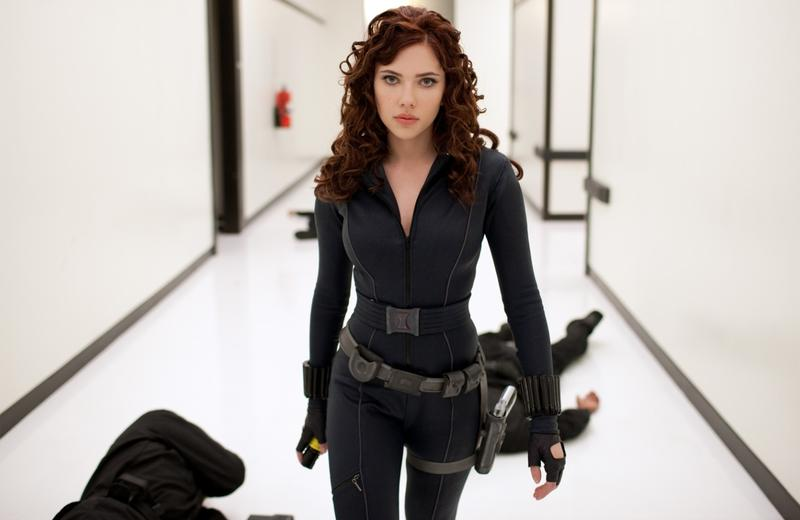Imagine the next scene in this story. In the next scene, the camera could pan out to reveal Black Widow bracing herself as more adversaries appear at the end of the corridor. Drawing her weapons from her holsters, she prepares for another intense showdown, her eyes glinting with determination. The white hallway's stark contrast with her dark attire emphasizes the impending clash, setting the stage for a high-octane action sequence. 